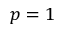<formula> <loc_0><loc_0><loc_500><loc_500>p = 1</formula> 